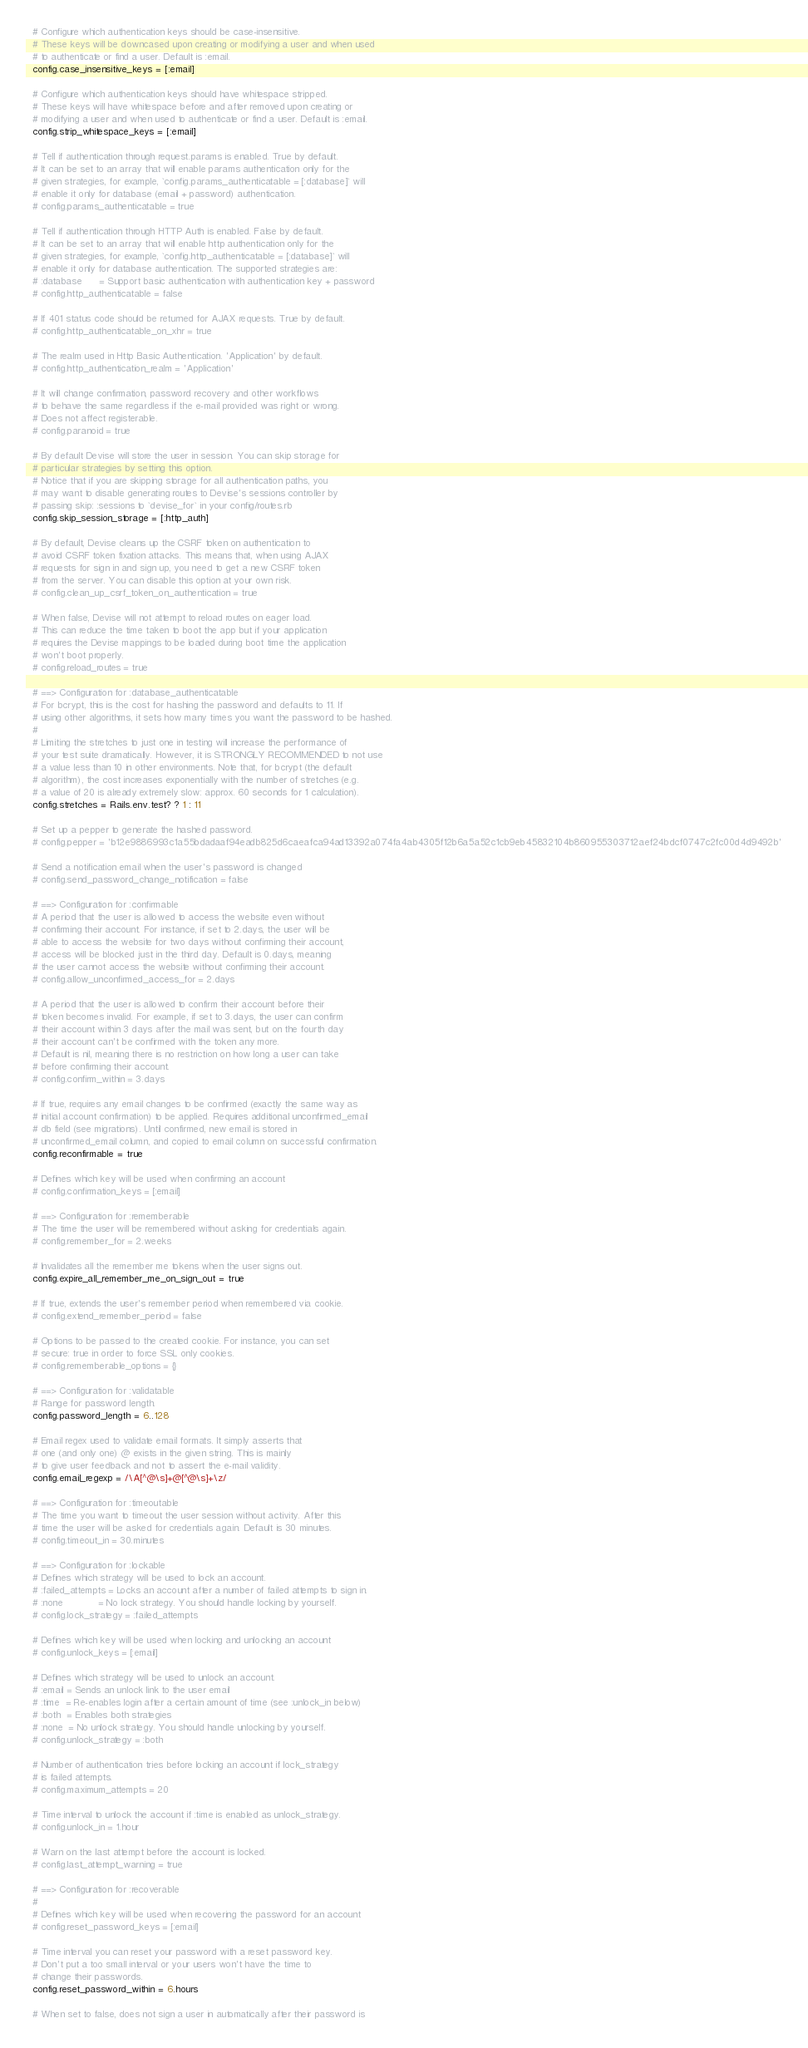<code> <loc_0><loc_0><loc_500><loc_500><_Ruby_>  # Configure which authentication keys should be case-insensitive.
  # These keys will be downcased upon creating or modifying a user and when used
  # to authenticate or find a user. Default is :email.
  config.case_insensitive_keys = [:email]

  # Configure which authentication keys should have whitespace stripped.
  # These keys will have whitespace before and after removed upon creating or
  # modifying a user and when used to authenticate or find a user. Default is :email.
  config.strip_whitespace_keys = [:email]

  # Tell if authentication through request.params is enabled. True by default.
  # It can be set to an array that will enable params authentication only for the
  # given strategies, for example, `config.params_authenticatable = [:database]` will
  # enable it only for database (email + password) authentication.
  # config.params_authenticatable = true

  # Tell if authentication through HTTP Auth is enabled. False by default.
  # It can be set to an array that will enable http authentication only for the
  # given strategies, for example, `config.http_authenticatable = [:database]` will
  # enable it only for database authentication. The supported strategies are:
  # :database      = Support basic authentication with authentication key + password
  # config.http_authenticatable = false

  # If 401 status code should be returned for AJAX requests. True by default.
  # config.http_authenticatable_on_xhr = true

  # The realm used in Http Basic Authentication. 'Application' by default.
  # config.http_authentication_realm = 'Application'

  # It will change confirmation, password recovery and other workflows
  # to behave the same regardless if the e-mail provided was right or wrong.
  # Does not affect registerable.
  # config.paranoid = true

  # By default Devise will store the user in session. You can skip storage for
  # particular strategies by setting this option.
  # Notice that if you are skipping storage for all authentication paths, you
  # may want to disable generating routes to Devise's sessions controller by
  # passing skip: :sessions to `devise_for` in your config/routes.rb
  config.skip_session_storage = [:http_auth]

  # By default, Devise cleans up the CSRF token on authentication to
  # avoid CSRF token fixation attacks. This means that, when using AJAX
  # requests for sign in and sign up, you need to get a new CSRF token
  # from the server. You can disable this option at your own risk.
  # config.clean_up_csrf_token_on_authentication = true

  # When false, Devise will not attempt to reload routes on eager load.
  # This can reduce the time taken to boot the app but if your application
  # requires the Devise mappings to be loaded during boot time the application
  # won't boot properly.
  # config.reload_routes = true

  # ==> Configuration for :database_authenticatable
  # For bcrypt, this is the cost for hashing the password and defaults to 11. If
  # using other algorithms, it sets how many times you want the password to be hashed.
  #
  # Limiting the stretches to just one in testing will increase the performance of
  # your test suite dramatically. However, it is STRONGLY RECOMMENDED to not use
  # a value less than 10 in other environments. Note that, for bcrypt (the default
  # algorithm), the cost increases exponentially with the number of stretches (e.g.
  # a value of 20 is already extremely slow: approx. 60 seconds for 1 calculation).
  config.stretches = Rails.env.test? ? 1 : 11

  # Set up a pepper to generate the hashed password.
  # config.pepper = 'b12e9886993c1a55bdadaaf94eadb825d6caeafca94ad13392a074fa4ab4305f12b6a5a52c1cb9eb45832104b860955303712aef24bdcf0747c2fc00d4d9492b'

  # Send a notification email when the user's password is changed
  # config.send_password_change_notification = false

  # ==> Configuration for :confirmable
  # A period that the user is allowed to access the website even without
  # confirming their account. For instance, if set to 2.days, the user will be
  # able to access the website for two days without confirming their account,
  # access will be blocked just in the third day. Default is 0.days, meaning
  # the user cannot access the website without confirming their account.
  # config.allow_unconfirmed_access_for = 2.days

  # A period that the user is allowed to confirm their account before their
  # token becomes invalid. For example, if set to 3.days, the user can confirm
  # their account within 3 days after the mail was sent, but on the fourth day
  # their account can't be confirmed with the token any more.
  # Default is nil, meaning there is no restriction on how long a user can take
  # before confirming their account.
  # config.confirm_within = 3.days

  # If true, requires any email changes to be confirmed (exactly the same way as
  # initial account confirmation) to be applied. Requires additional unconfirmed_email
  # db field (see migrations). Until confirmed, new email is stored in
  # unconfirmed_email column, and copied to email column on successful confirmation.
  config.reconfirmable = true

  # Defines which key will be used when confirming an account
  # config.confirmation_keys = [:email]

  # ==> Configuration for :rememberable
  # The time the user will be remembered without asking for credentials again.
  # config.remember_for = 2.weeks

  # Invalidates all the remember me tokens when the user signs out.
  config.expire_all_remember_me_on_sign_out = true

  # If true, extends the user's remember period when remembered via cookie.
  # config.extend_remember_period = false

  # Options to be passed to the created cookie. For instance, you can set
  # secure: true in order to force SSL only cookies.
  # config.rememberable_options = {}

  # ==> Configuration for :validatable
  # Range for password length.
  config.password_length = 6..128

  # Email regex used to validate email formats. It simply asserts that
  # one (and only one) @ exists in the given string. This is mainly
  # to give user feedback and not to assert the e-mail validity.
  config.email_regexp = /\A[^@\s]+@[^@\s]+\z/

  # ==> Configuration for :timeoutable
  # The time you want to timeout the user session without activity. After this
  # time the user will be asked for credentials again. Default is 30 minutes.
  # config.timeout_in = 30.minutes

  # ==> Configuration for :lockable
  # Defines which strategy will be used to lock an account.
  # :failed_attempts = Locks an account after a number of failed attempts to sign in.
  # :none            = No lock strategy. You should handle locking by yourself.
  # config.lock_strategy = :failed_attempts

  # Defines which key will be used when locking and unlocking an account
  # config.unlock_keys = [:email]

  # Defines which strategy will be used to unlock an account.
  # :email = Sends an unlock link to the user email
  # :time  = Re-enables login after a certain amount of time (see :unlock_in below)
  # :both  = Enables both strategies
  # :none  = No unlock strategy. You should handle unlocking by yourself.
  # config.unlock_strategy = :both

  # Number of authentication tries before locking an account if lock_strategy
  # is failed attempts.
  # config.maximum_attempts = 20

  # Time interval to unlock the account if :time is enabled as unlock_strategy.
  # config.unlock_in = 1.hour

  # Warn on the last attempt before the account is locked.
  # config.last_attempt_warning = true

  # ==> Configuration for :recoverable
  #
  # Defines which key will be used when recovering the password for an account
  # config.reset_password_keys = [:email]

  # Time interval you can reset your password with a reset password key.
  # Don't put a too small interval or your users won't have the time to
  # change their passwords.
  config.reset_password_within = 6.hours

  # When set to false, does not sign a user in automatically after their password is</code> 